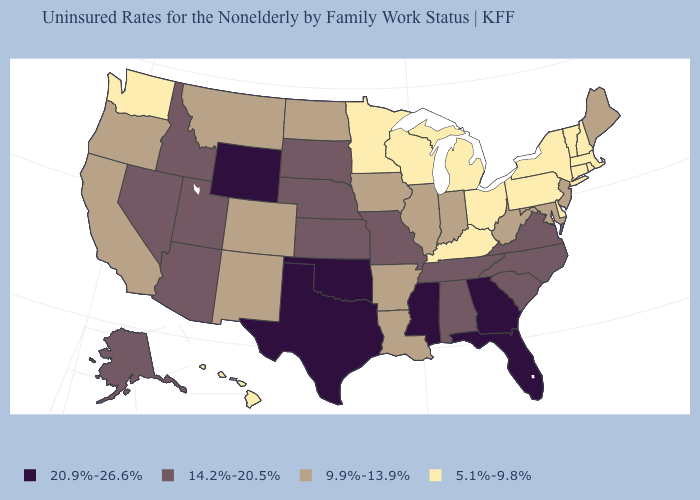What is the lowest value in the USA?
Concise answer only. 5.1%-9.8%. Which states hav the highest value in the South?
Answer briefly. Florida, Georgia, Mississippi, Oklahoma, Texas. Which states have the lowest value in the Northeast?
Give a very brief answer. Connecticut, Massachusetts, New Hampshire, New York, Pennsylvania, Rhode Island, Vermont. How many symbols are there in the legend?
Concise answer only. 4. What is the value of Pennsylvania?
Give a very brief answer. 5.1%-9.8%. Does Texas have the lowest value in the USA?
Short answer required. No. Name the states that have a value in the range 20.9%-26.6%?
Write a very short answer. Florida, Georgia, Mississippi, Oklahoma, Texas, Wyoming. What is the value of Louisiana?
Answer briefly. 9.9%-13.9%. Name the states that have a value in the range 20.9%-26.6%?
Give a very brief answer. Florida, Georgia, Mississippi, Oklahoma, Texas, Wyoming. Among the states that border Vermont , which have the lowest value?
Short answer required. Massachusetts, New Hampshire, New York. Name the states that have a value in the range 5.1%-9.8%?
Keep it brief. Connecticut, Delaware, Hawaii, Kentucky, Massachusetts, Michigan, Minnesota, New Hampshire, New York, Ohio, Pennsylvania, Rhode Island, Vermont, Washington, Wisconsin. Does Oregon have the lowest value in the West?
Keep it brief. No. What is the value of Utah?
Concise answer only. 14.2%-20.5%. What is the value of Idaho?
Be succinct. 14.2%-20.5%. Does Ohio have a lower value than Massachusetts?
Write a very short answer. No. 